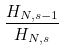Convert formula to latex. <formula><loc_0><loc_0><loc_500><loc_500>\frac { H _ { N , s - 1 } } { H _ { N , s } }</formula> 